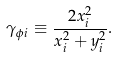Convert formula to latex. <formula><loc_0><loc_0><loc_500><loc_500>\gamma _ { \phi i } \equiv \frac { 2 x ^ { 2 } _ { i } } { x ^ { 2 } _ { i } + y ^ { 2 } _ { i } } .</formula> 